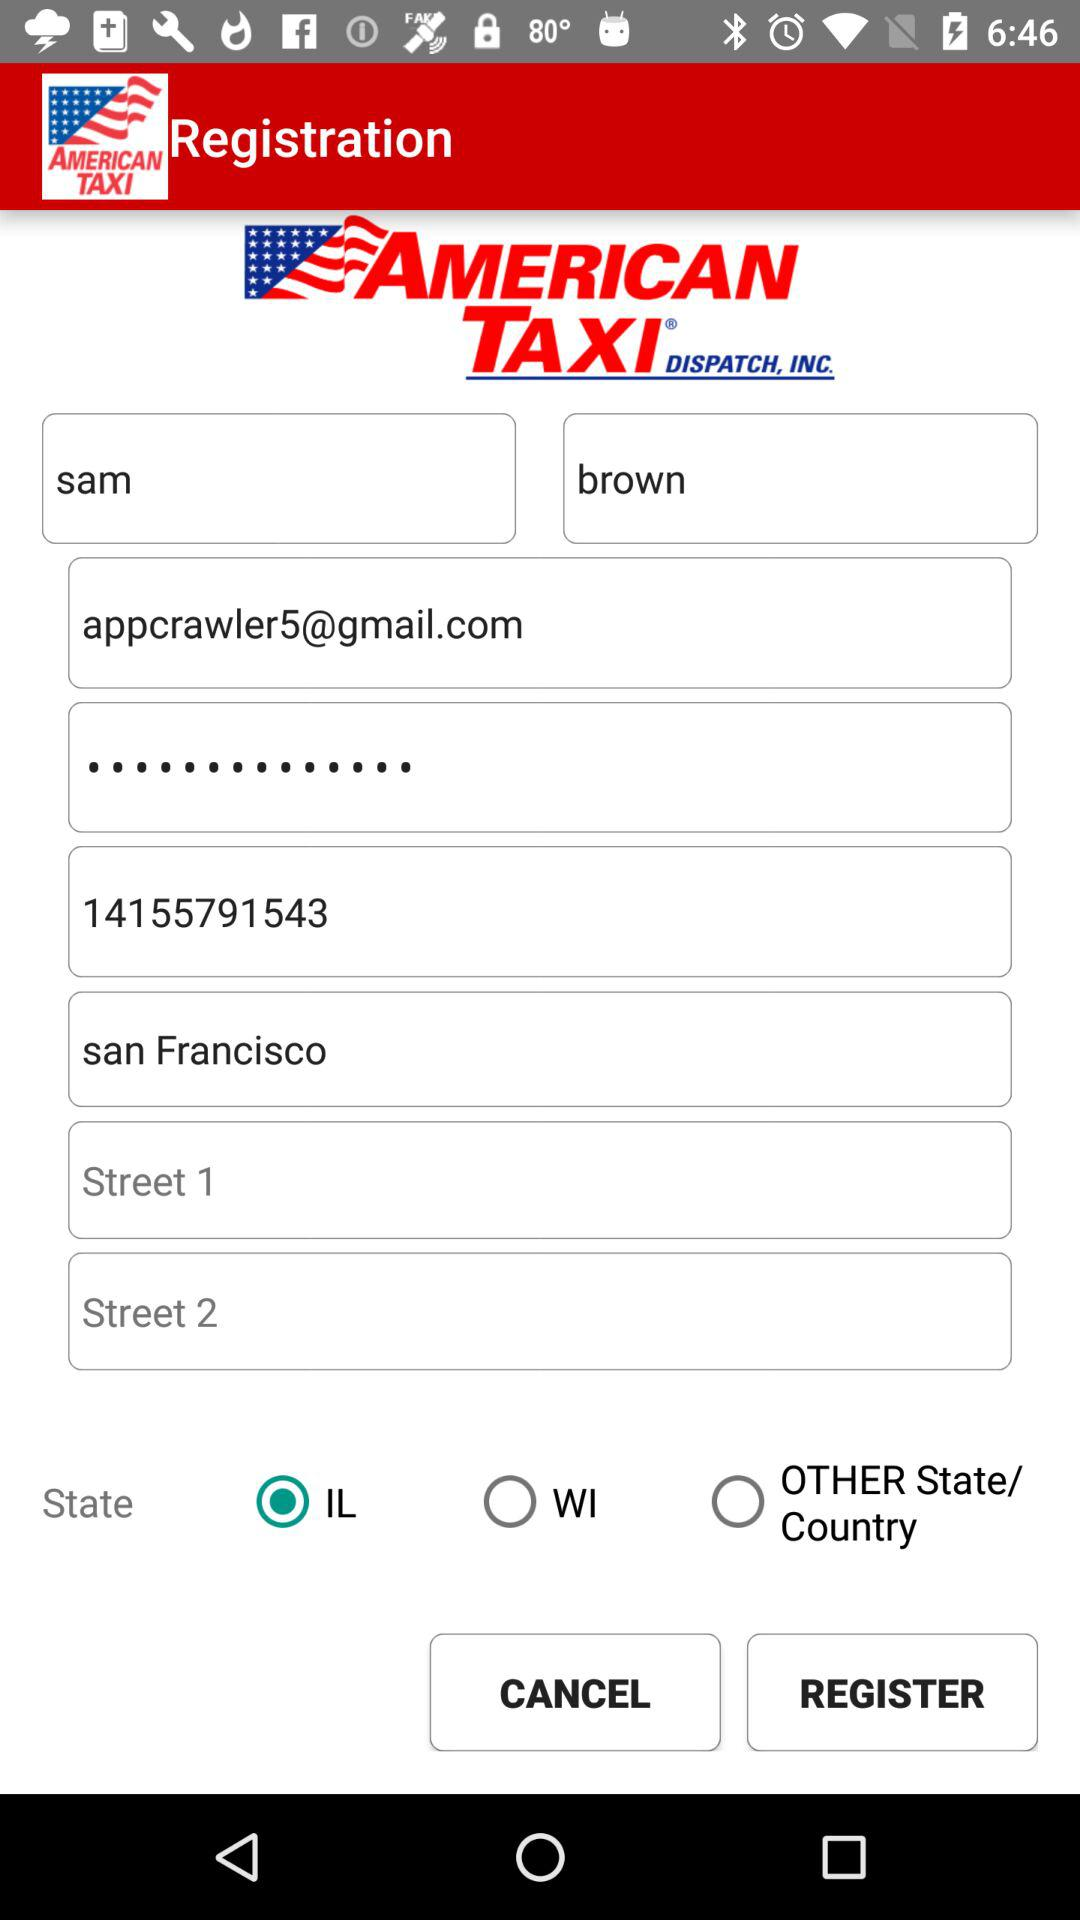Which state is selected? The selected state is "Illinois". 